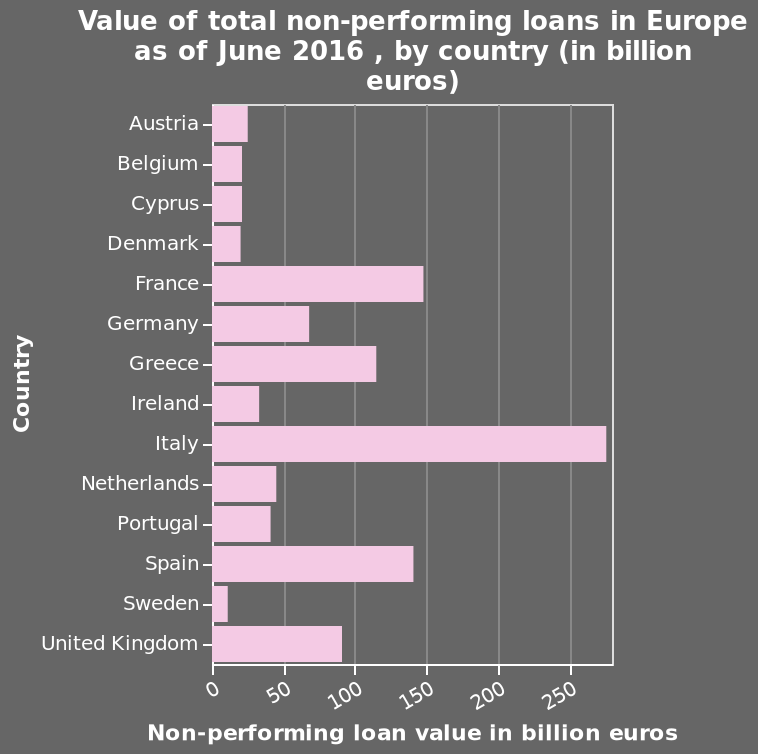<image>
Which country has the highest value of non-performing loans in Europe? The country with the highest value of non-performing loans in Europe is not mentioned in the description. please describe the details of the chart Value of total non-performing loans in Europe as of June 2016 , by country (in billion euros) is a bar diagram. The x-axis measures Non-performing loan value in billion euros using linear scale from 0 to 250 while the y-axis shows Country on categorical scale from Austria to United Kingdom. 